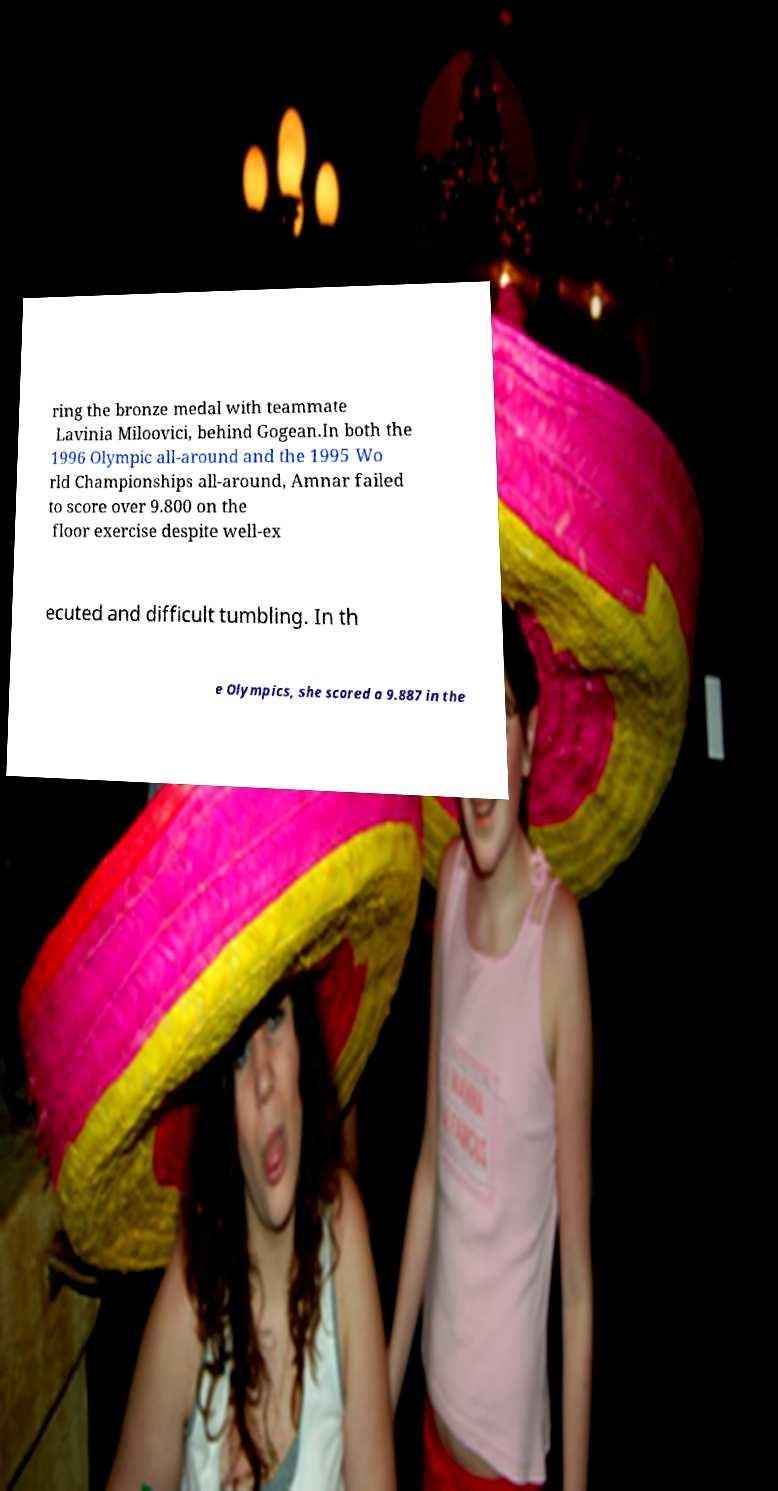Can you accurately transcribe the text from the provided image for me? ring the bronze medal with teammate Lavinia Miloovici, behind Gogean.In both the 1996 Olympic all-around and the 1995 Wo rld Championships all-around, Amnar failed to score over 9.800 on the floor exercise despite well-ex ecuted and difficult tumbling. In th e Olympics, she scored a 9.887 in the 